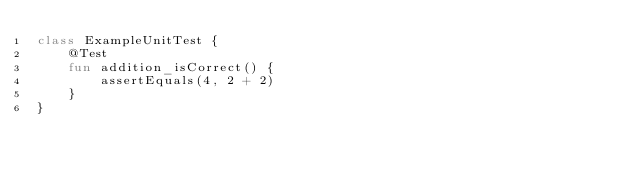<code> <loc_0><loc_0><loc_500><loc_500><_Kotlin_>class ExampleUnitTest {
    @Test
    fun addition_isCorrect() {
        assertEquals(4, 2 + 2)
    }
}</code> 